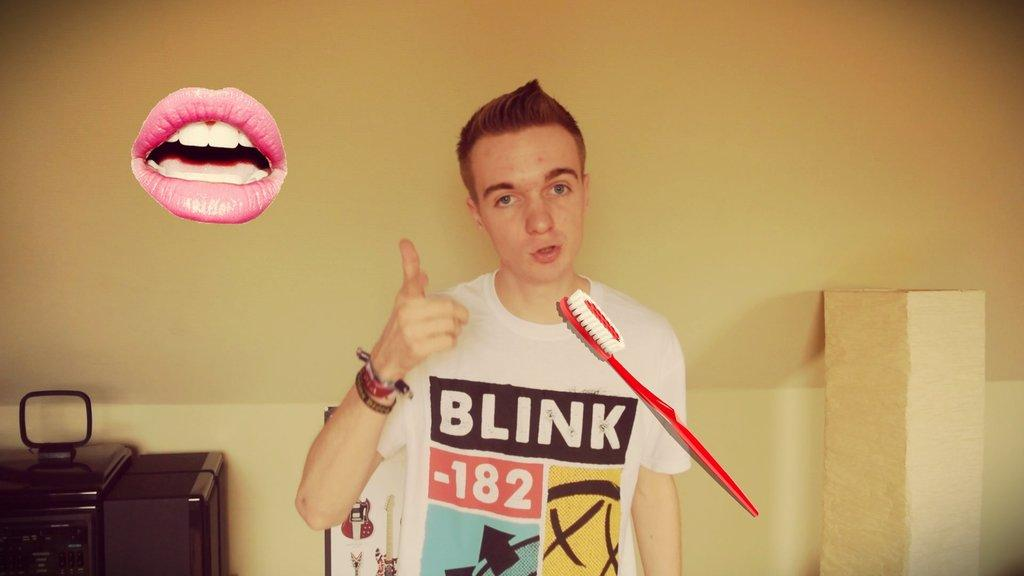<image>
Summarize the visual content of the image. Man wearing a white t-shirt which says Blink 182 on it. 